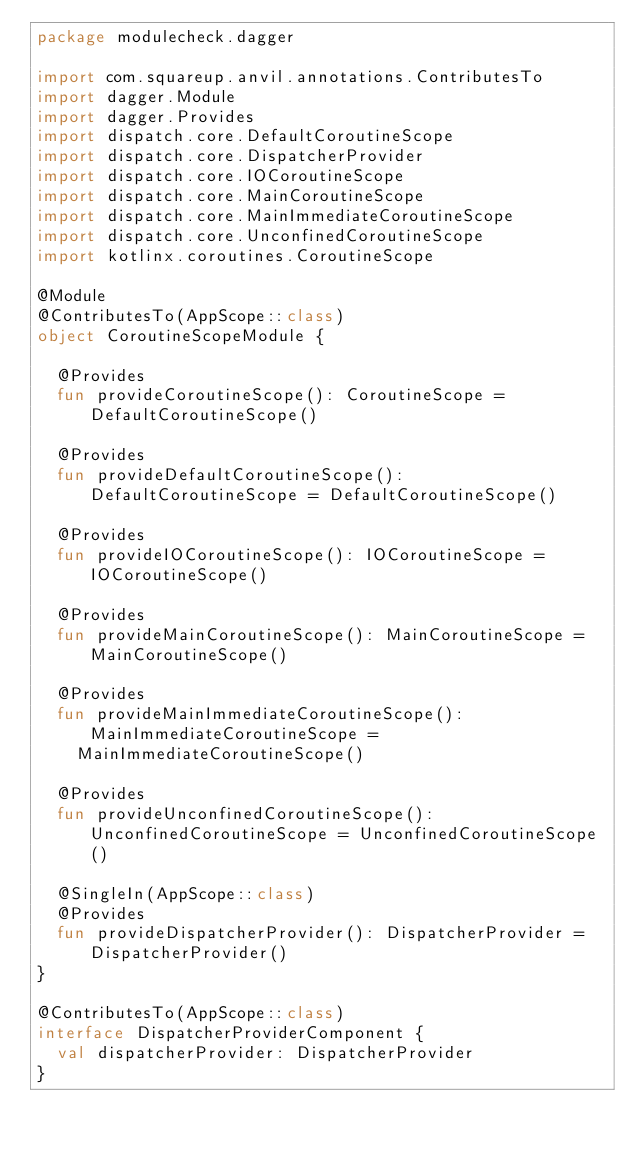Convert code to text. <code><loc_0><loc_0><loc_500><loc_500><_Kotlin_>package modulecheck.dagger

import com.squareup.anvil.annotations.ContributesTo
import dagger.Module
import dagger.Provides
import dispatch.core.DefaultCoroutineScope
import dispatch.core.DispatcherProvider
import dispatch.core.IOCoroutineScope
import dispatch.core.MainCoroutineScope
import dispatch.core.MainImmediateCoroutineScope
import dispatch.core.UnconfinedCoroutineScope
import kotlinx.coroutines.CoroutineScope

@Module
@ContributesTo(AppScope::class)
object CoroutineScopeModule {

  @Provides
  fun provideCoroutineScope(): CoroutineScope = DefaultCoroutineScope()

  @Provides
  fun provideDefaultCoroutineScope(): DefaultCoroutineScope = DefaultCoroutineScope()

  @Provides
  fun provideIOCoroutineScope(): IOCoroutineScope = IOCoroutineScope()

  @Provides
  fun provideMainCoroutineScope(): MainCoroutineScope = MainCoroutineScope()

  @Provides
  fun provideMainImmediateCoroutineScope(): MainImmediateCoroutineScope =
    MainImmediateCoroutineScope()

  @Provides
  fun provideUnconfinedCoroutineScope(): UnconfinedCoroutineScope = UnconfinedCoroutineScope()

  @SingleIn(AppScope::class)
  @Provides
  fun provideDispatcherProvider(): DispatcherProvider = DispatcherProvider()
}

@ContributesTo(AppScope::class)
interface DispatcherProviderComponent {
  val dispatcherProvider: DispatcherProvider
}
</code> 